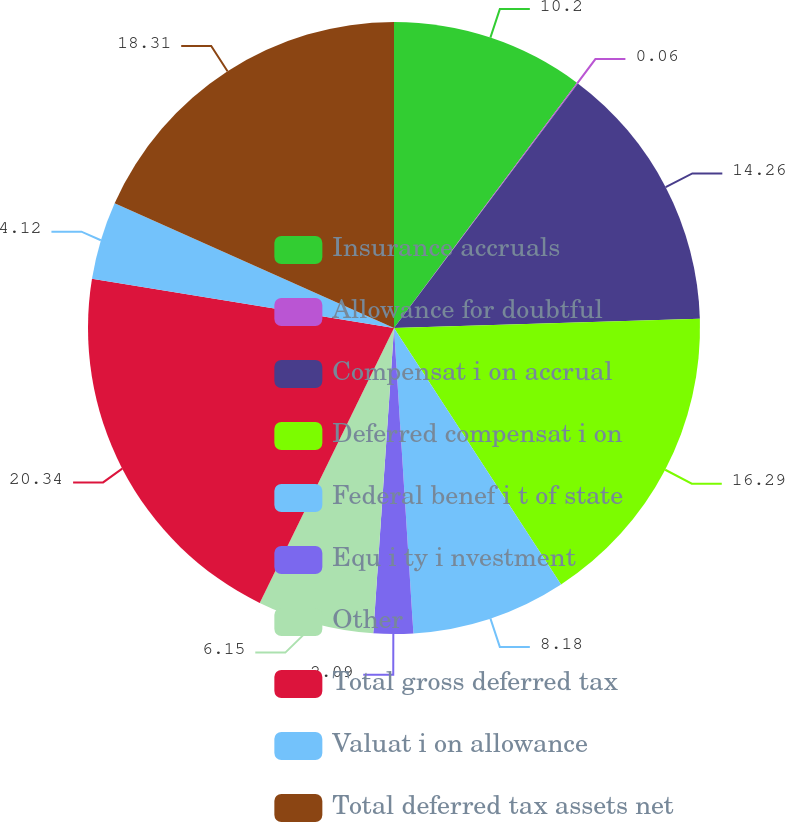Convert chart. <chart><loc_0><loc_0><loc_500><loc_500><pie_chart><fcel>Insurance accruals<fcel>Allowance for doubtful<fcel>Compensat i on accrual<fcel>Deferred compensat i on<fcel>Federal benef i t of state<fcel>Equ i ty i nvestment<fcel>Other<fcel>Total gross deferred tax<fcel>Valuat i on allowance<fcel>Total deferred tax assets net<nl><fcel>10.2%<fcel>0.06%<fcel>14.26%<fcel>16.29%<fcel>8.18%<fcel>2.09%<fcel>6.15%<fcel>20.34%<fcel>4.12%<fcel>18.31%<nl></chart> 